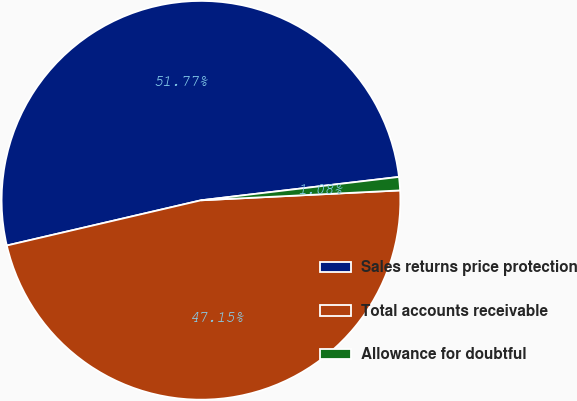Convert chart. <chart><loc_0><loc_0><loc_500><loc_500><pie_chart><fcel>Sales returns price protection<fcel>Total accounts receivable<fcel>Allowance for doubtful<nl><fcel>51.77%<fcel>47.15%<fcel>1.08%<nl></chart> 